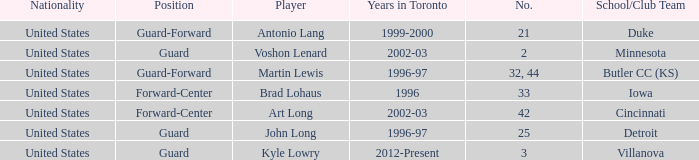How many schools did player number 3 play at? 1.0. 